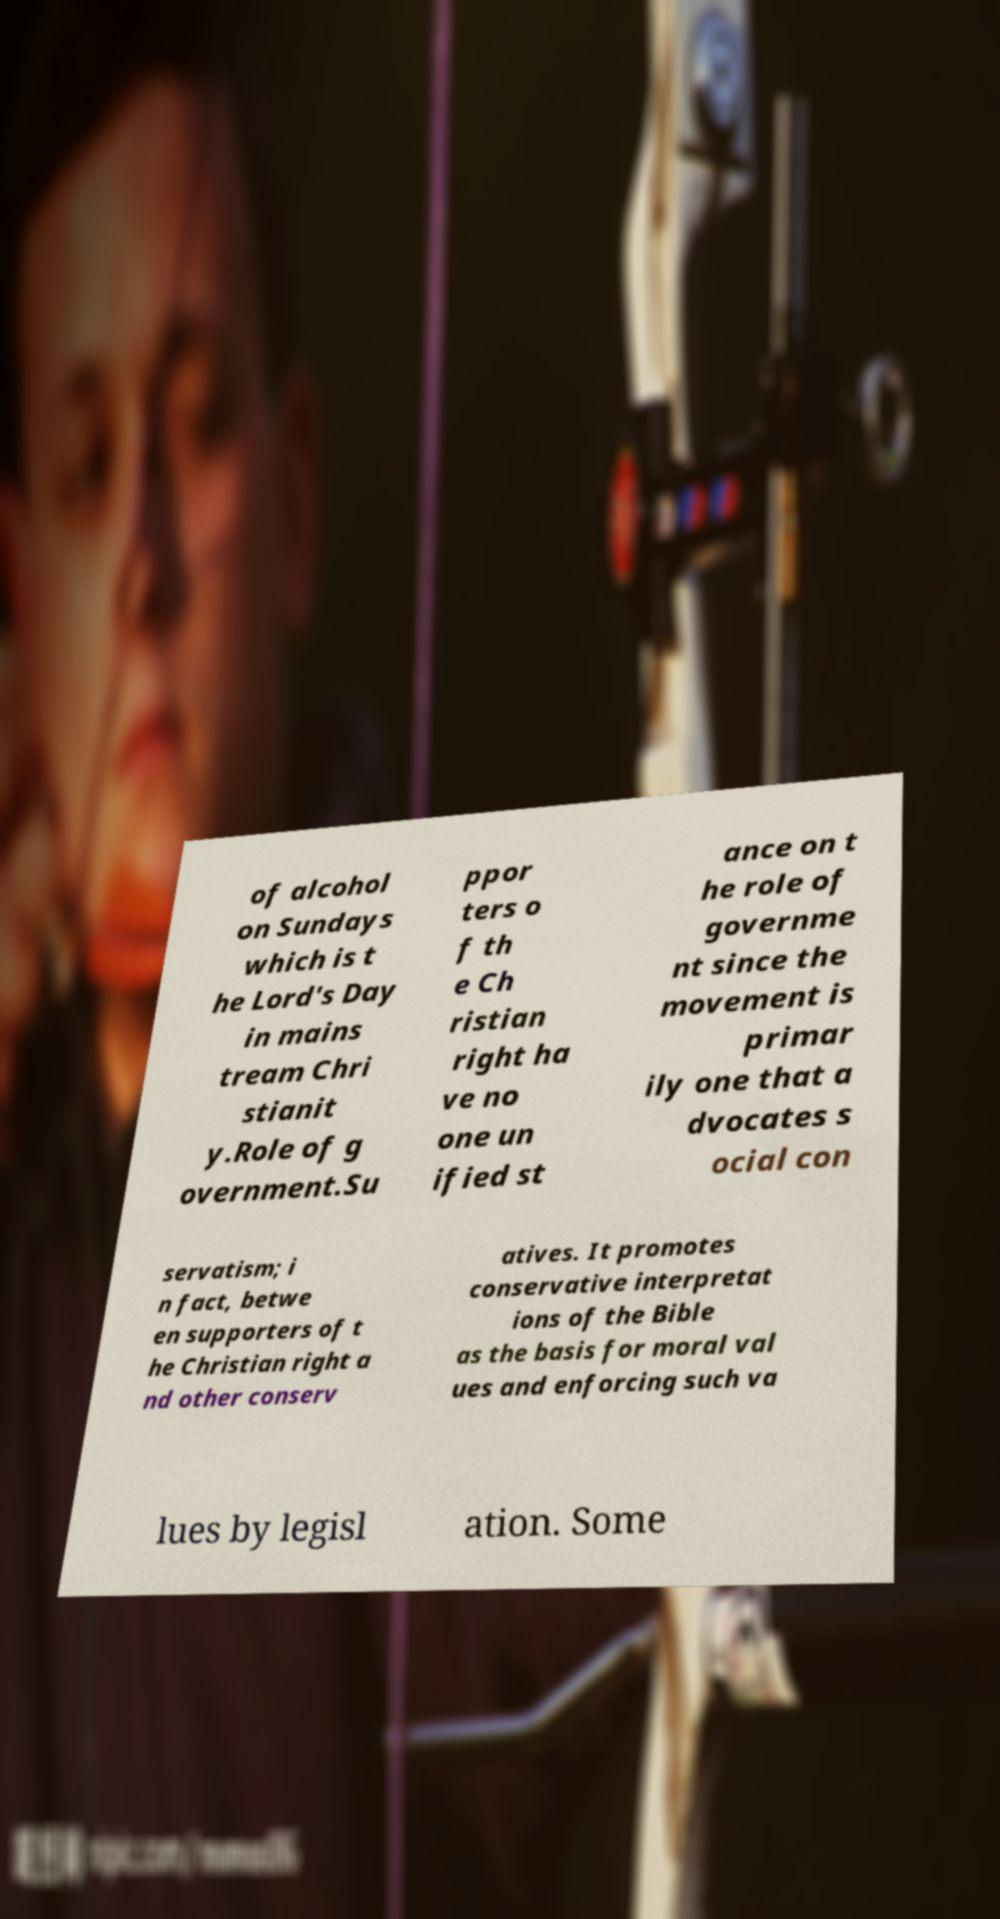Could you assist in decoding the text presented in this image and type it out clearly? of alcohol on Sundays which is t he Lord's Day in mains tream Chri stianit y.Role of g overnment.Su ppor ters o f th e Ch ristian right ha ve no one un ified st ance on t he role of governme nt since the movement is primar ily one that a dvocates s ocial con servatism; i n fact, betwe en supporters of t he Christian right a nd other conserv atives. It promotes conservative interpretat ions of the Bible as the basis for moral val ues and enforcing such va lues by legisl ation. Some 